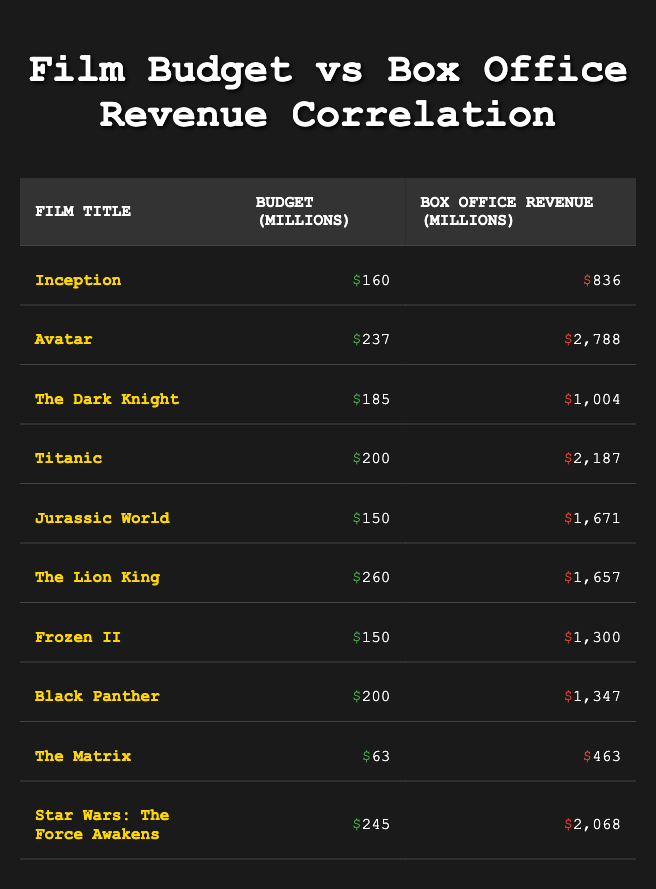What is the budget of "Star Wars: The Force Awakens"? The table lists the budget for each film. By finding "Star Wars: The Force Awakens" in the table, we see the associated budget is listed in the Budget column as 245 million.
Answer: 245 million Which film has the highest box office revenue? The box office revenue is listed in the table for each film. Scanning through the Box Office Revenue column, "Avatar" has the highest revenue, recorded as 2788 million.
Answer: Avatar What is the average budget of all the films listed? To find the average budget, first calculate the sum of all budgets: 160 + 237 + 185 + 200 + 150 + 260 + 150 + 200 + 63 + 245 = 1,770 million. Since there are 10 films, the average budget is 1,770 / 10 = 177 million.
Answer: 177 million Is "The Lion King" budget more than 250 million? By checking the Budget column for "The Lion King", we see that the budget is 260 million. Since 260 million is more than 250 million, the statement is true.
Answer: Yes How much more box office revenue did "Titanic" generate compared to "Frozen II"? "Titanic" has a box office revenue of 2187 million and "Frozen II" has 1300 million. The difference in revenue is calculated as 2187 - 1300 = 887 million.
Answer: 887 million Which film has a budget less than 100 million? The table shows that none of the films have a budget less than 100 million, with the lowest being "The Matrix" at 63 million. Therefore, the statement is false.
Answer: No How many films have a budget of 200 million or more? By examining the Budget column, the films with budgets of 200 million or more are "Avatar", "Titanic", "The Lion King", "Black Panther", and "Star Wars: The Force Awakens" - totaling 5 films.
Answer: 5 What is the total box office revenue for all the films listed? To find the total box office revenue, sum all values in the Box Office Revenue column: 836 + 2788 + 1004 + 2187 + 1671 + 1657 + 1300 + 1347 + 463 + 2068 = 12,022 million.
Answer: 12,022 million What is the budget-to-revenue ratio for "Jurassic World"? The budget for "Jurassic World" is 150 million, and the box office revenue is 1671 million. The ratio is calculated by dividing the budget by revenue: 150 / 1671 ≈ 0.0897 or approximately 1:11.
Answer: Approximately 1:11 